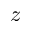<formula> <loc_0><loc_0><loc_500><loc_500>z</formula> 